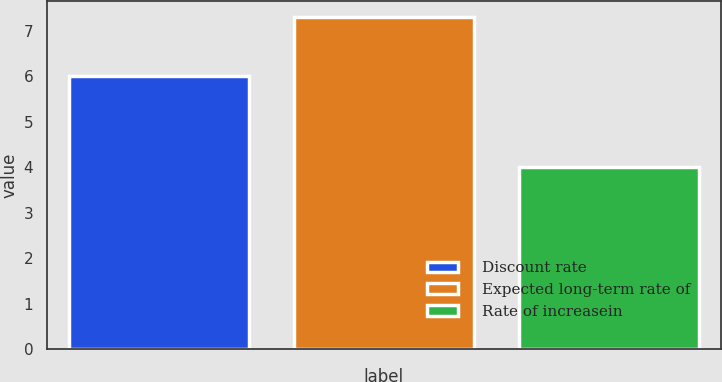Convert chart. <chart><loc_0><loc_0><loc_500><loc_500><bar_chart><fcel>Discount rate<fcel>Expected long-term rate of<fcel>Rate of increasein<nl><fcel>6<fcel>7.3<fcel>4<nl></chart> 